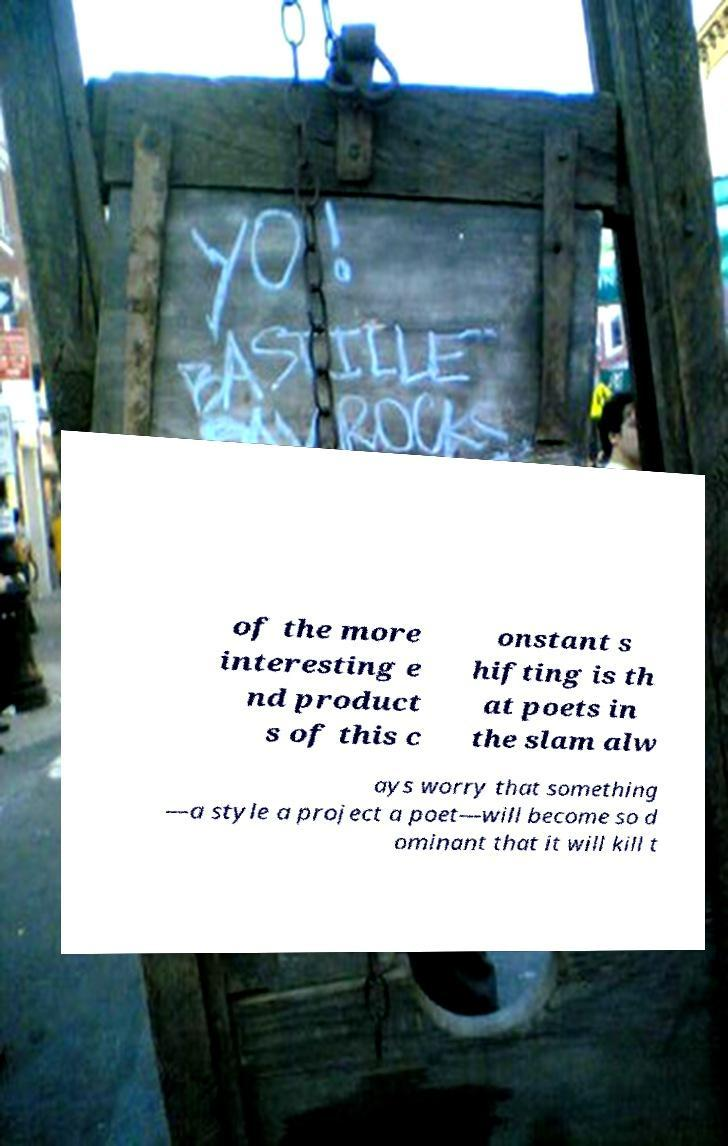I need the written content from this picture converted into text. Can you do that? of the more interesting e nd product s of this c onstant s hifting is th at poets in the slam alw ays worry that something —a style a project a poet—will become so d ominant that it will kill t 